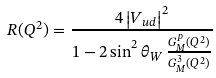Convert formula to latex. <formula><loc_0><loc_0><loc_500><loc_500>R ( Q ^ { 2 } ) = \frac { 4 \left | V _ { u d } \right | ^ { 2 } } { 1 - 2 \sin ^ { 2 } \theta _ { W } \, \frac { G _ { M } ^ { p } ( Q ^ { 2 } ) } { G _ { M } ^ { 3 } ( Q ^ { 2 } ) } }</formula> 